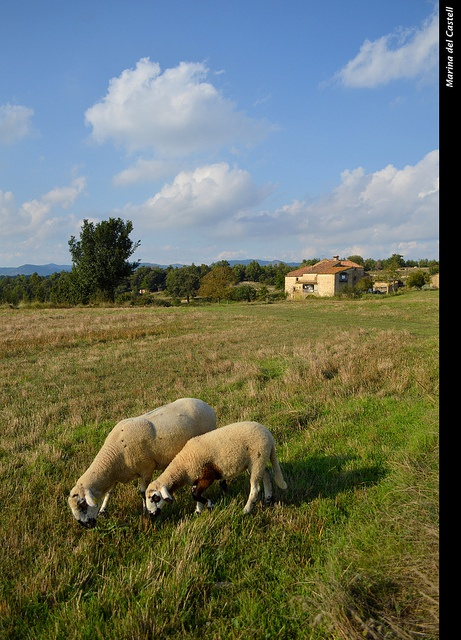Describe the objects in this image and their specific colors. I can see sheep in gray, olive, tan, and black tones and sheep in gray, black, tan, and olive tones in this image. 